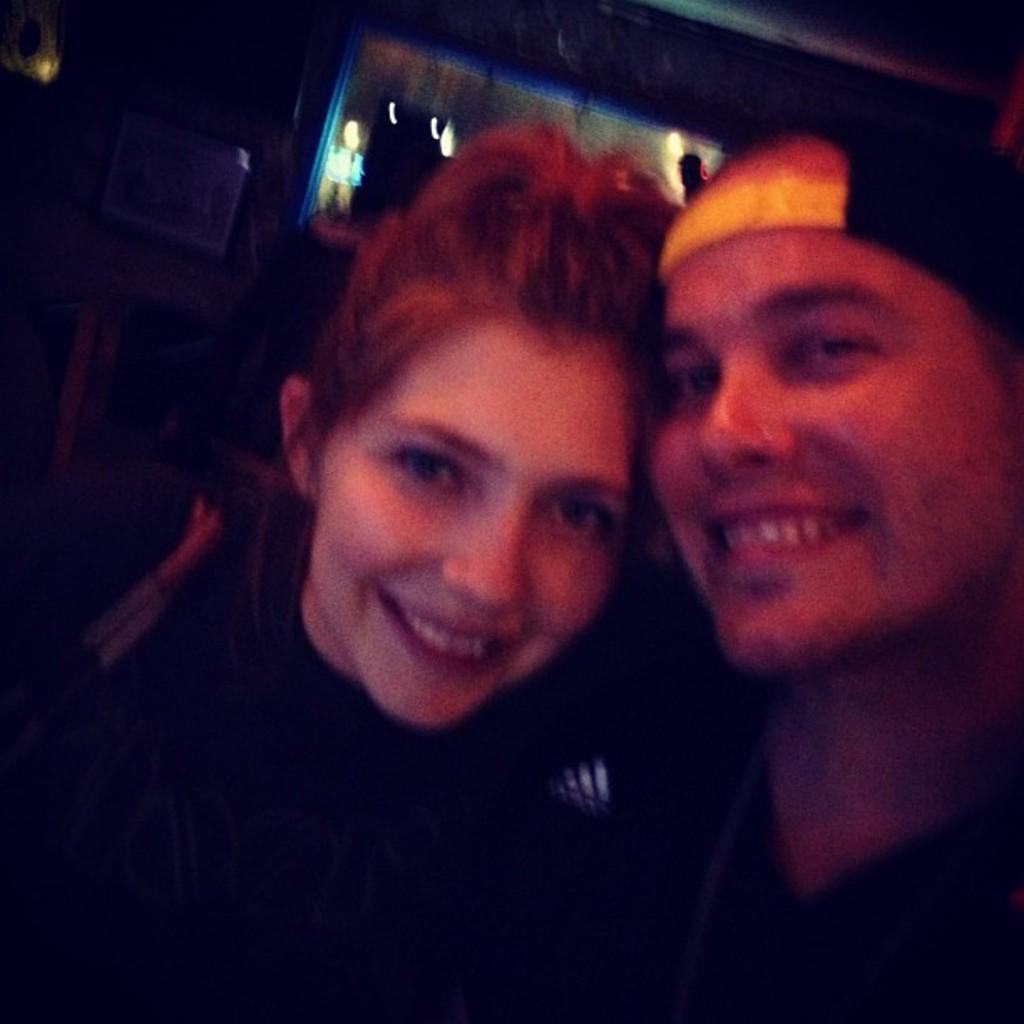How would you summarize this image in a sentence or two? In the picture I can see a man and a woman are smiling. The background of the image is blurred and dark. 